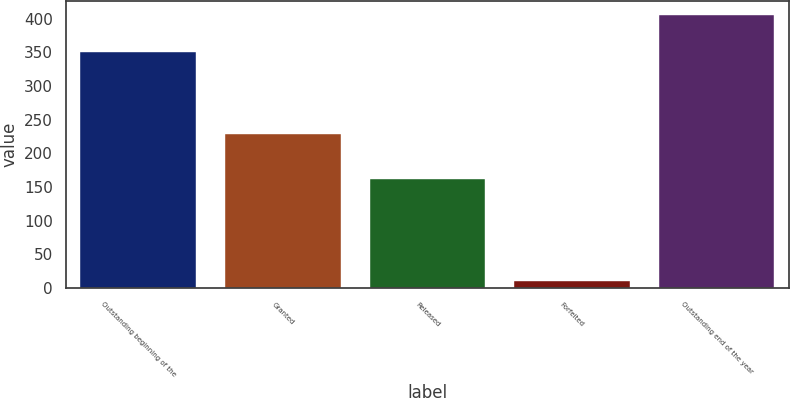<chart> <loc_0><loc_0><loc_500><loc_500><bar_chart><fcel>Outstanding beginning of the<fcel>Granted<fcel>Released<fcel>Forfeited<fcel>Outstanding end of the year<nl><fcel>350<fcel>228<fcel>162<fcel>10<fcel>406<nl></chart> 